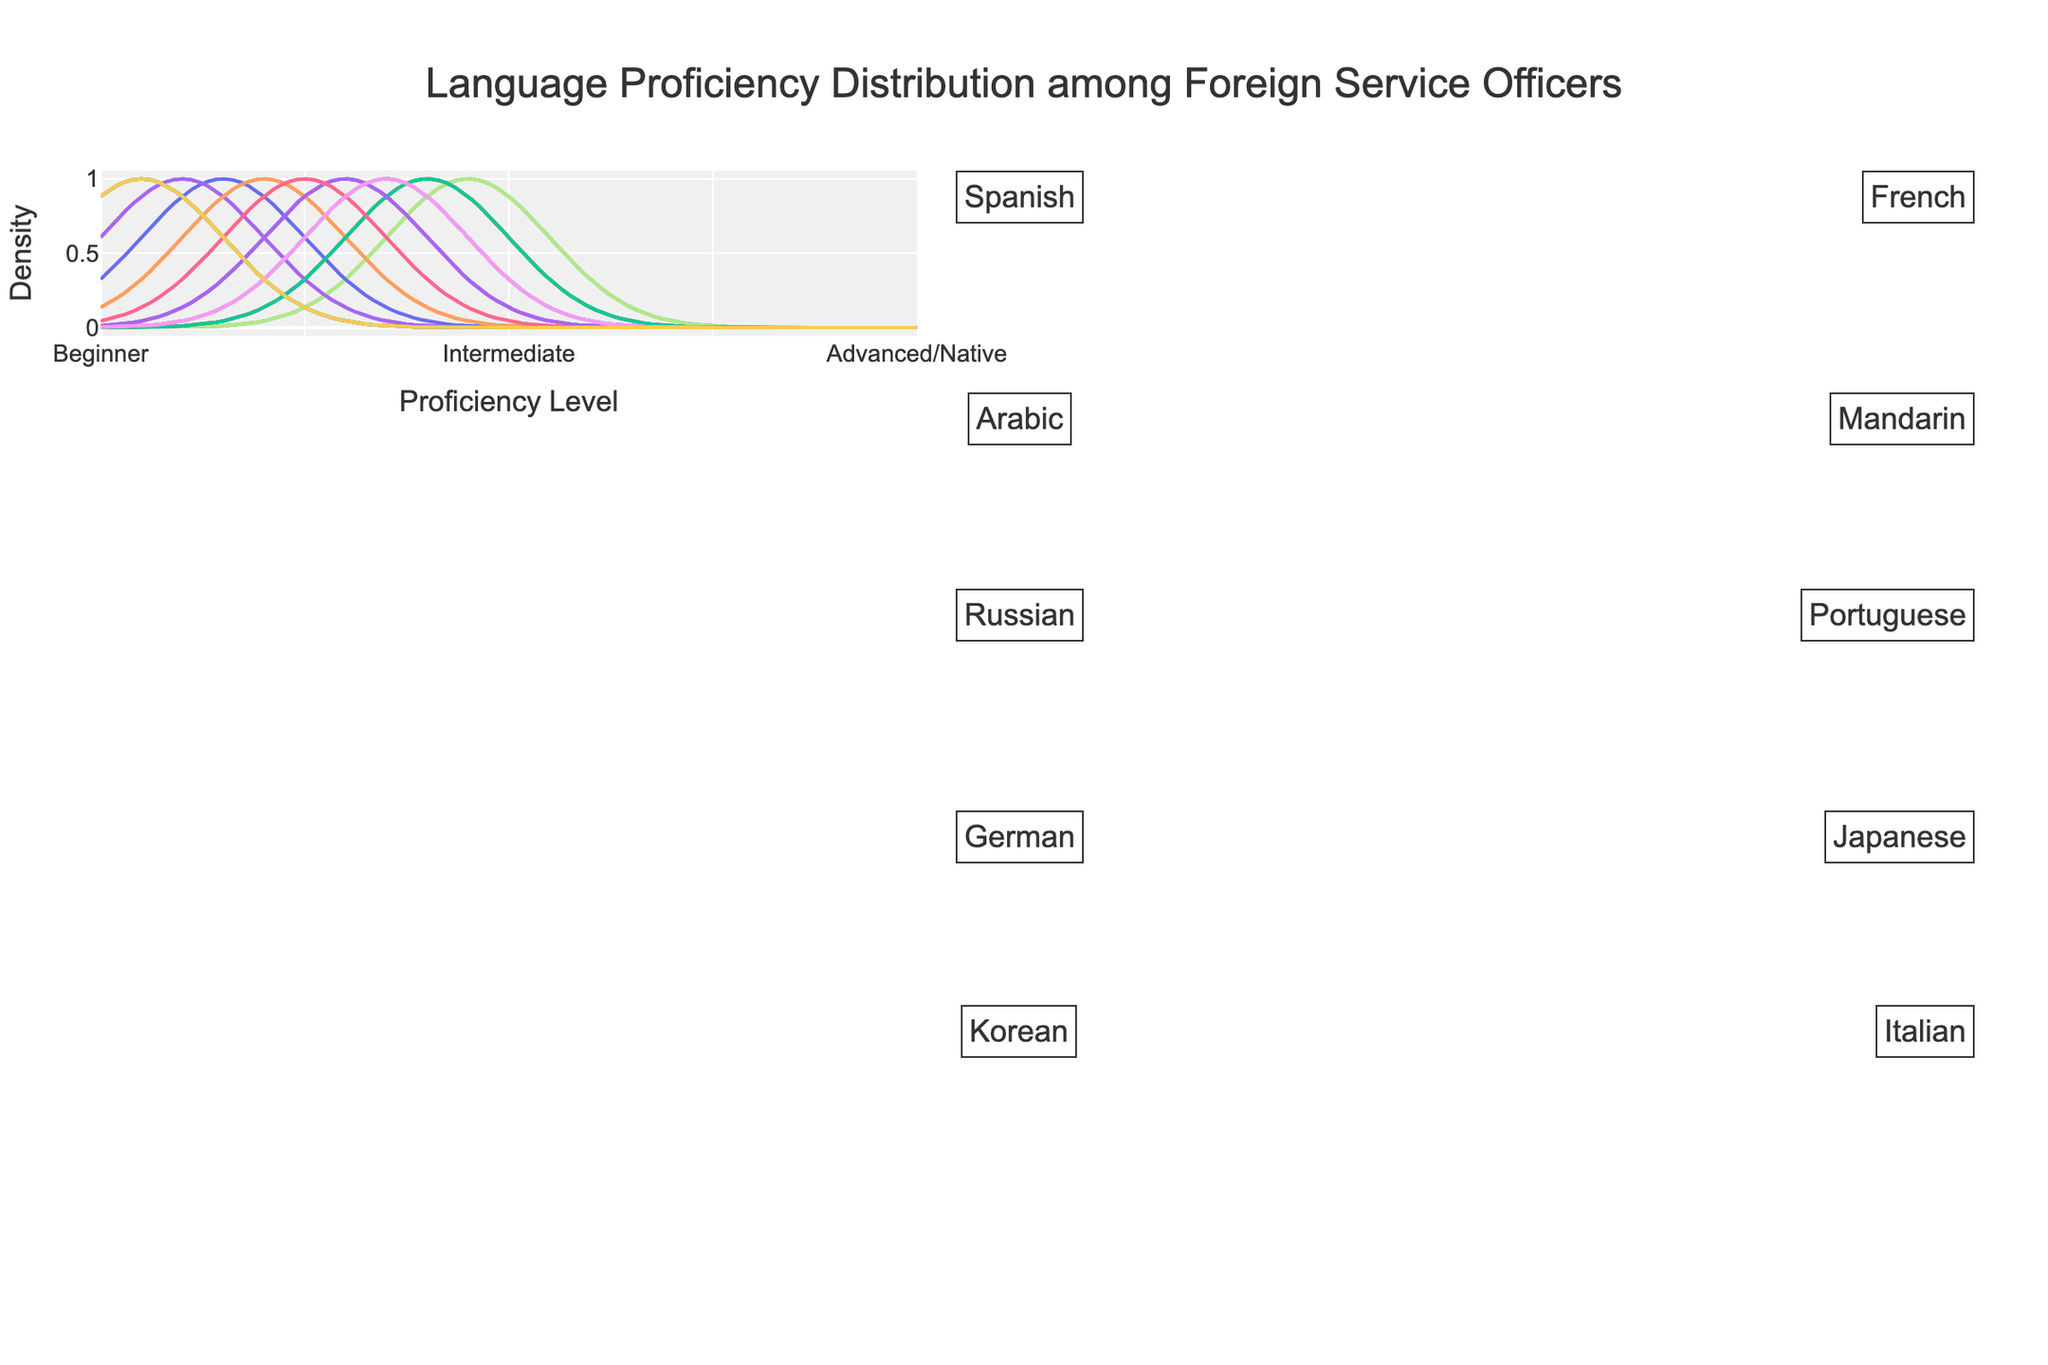what is the title of the figure? The title is displayed at the top of the figure. It reads "Language Proficiency Distribution among Foreign Service Officers," referring to the plot which shows varying proficiency levels for different languages.
Answer: Language Proficiency Distribution among Foreign Service Officers How many languages are represented in the figure? Each language has its individual annotation on the figure. Counting these annotations indicates the number of languages represented.
Answer: 10 Which language has the highest number of Intermediate proficiency officers? To determine this, locate the density plot associated with the Intermediate level for each language and identify which plot peaks the highest. Intermediate values for each language are: Spanish(35), French(40), Arabic(40), Mandarin(35), Russian(45), Portuguese(40), German(35), Japanese(30), Korean(30), Italian(35). Thus, Russian has the highest with 45.
Answer: Russian Among the languages displayed, which ones have the maximum number of Native speakers? The density plots for all languages at the Native level should be inspected. Spanish, French, and Portuguese each have 10 Native speakers while others have 5.
Answer: Spanish, French, Portuguese Compare the Beginner and Native proficiency levels for Korean. Which is higher? For each language's density plots, compare the heights of the Beginner and Native curves. Korean has 40 Beginners and 5 Native speakers, indicating Beginner is higher.
Answer: Beginner What language proficiency level does Italian have the most officers in? By examining the density plots corresponding to each proficiency level for Italian, the peak indicating 35 for both Intermediate and Advanced levels can be observed. Thus, Intermediate and Advanced are tied.
Answer: Intermediate, Advanced Which language has the most equal distribution across all proficiency levels? Compare the plots for an even spread across all four proficiency levels. Given other languages show variance, German shows closer values at Beginner(20), Intermediate(35), Advanced(40), Native(5), reflecting a more balanced distribution.
Answer: German Which language has the most officers at Beginner level? Inspect the density plot peaks for the Beginner level among all languages. Japanese has the highest peak of 35.
Answer: Japanese 